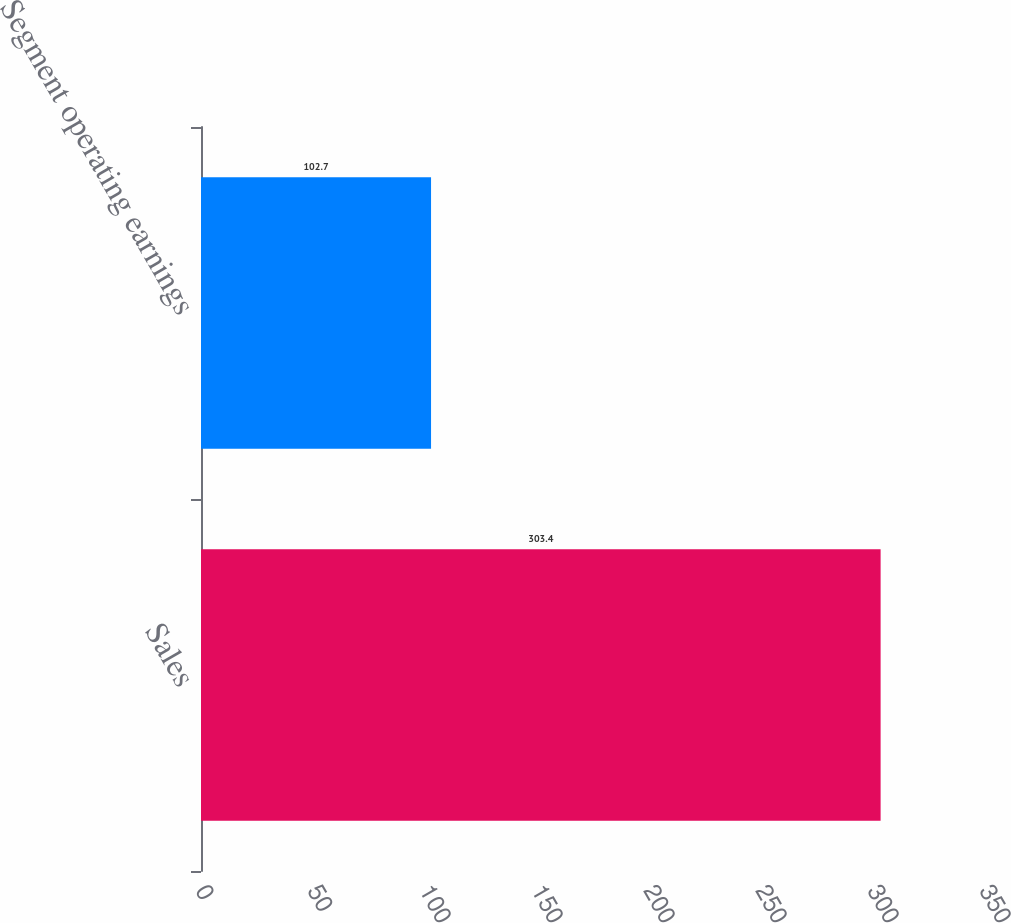Convert chart to OTSL. <chart><loc_0><loc_0><loc_500><loc_500><bar_chart><fcel>Sales<fcel>Segment operating earnings<nl><fcel>303.4<fcel>102.7<nl></chart> 